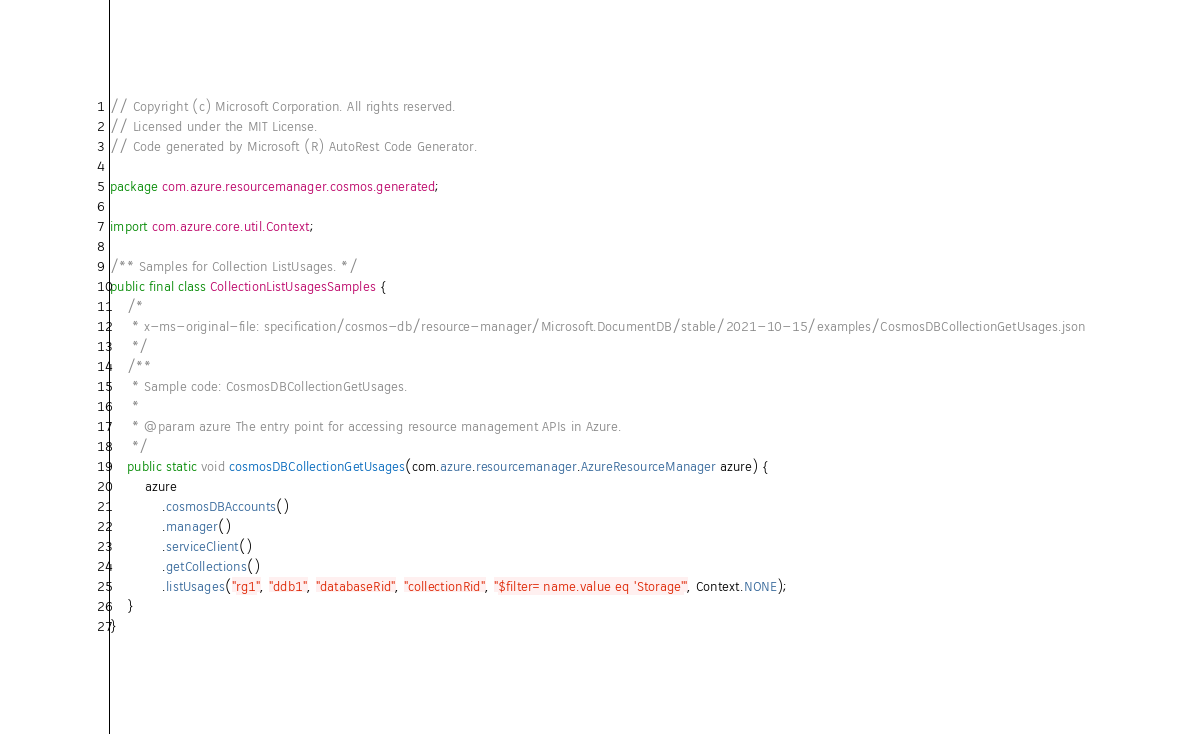<code> <loc_0><loc_0><loc_500><loc_500><_Java_>// Copyright (c) Microsoft Corporation. All rights reserved.
// Licensed under the MIT License.
// Code generated by Microsoft (R) AutoRest Code Generator.

package com.azure.resourcemanager.cosmos.generated;

import com.azure.core.util.Context;

/** Samples for Collection ListUsages. */
public final class CollectionListUsagesSamples {
    /*
     * x-ms-original-file: specification/cosmos-db/resource-manager/Microsoft.DocumentDB/stable/2021-10-15/examples/CosmosDBCollectionGetUsages.json
     */
    /**
     * Sample code: CosmosDBCollectionGetUsages.
     *
     * @param azure The entry point for accessing resource management APIs in Azure.
     */
    public static void cosmosDBCollectionGetUsages(com.azure.resourcemanager.AzureResourceManager azure) {
        azure
            .cosmosDBAccounts()
            .manager()
            .serviceClient()
            .getCollections()
            .listUsages("rg1", "ddb1", "databaseRid", "collectionRid", "$filter=name.value eq 'Storage'", Context.NONE);
    }
}
</code> 